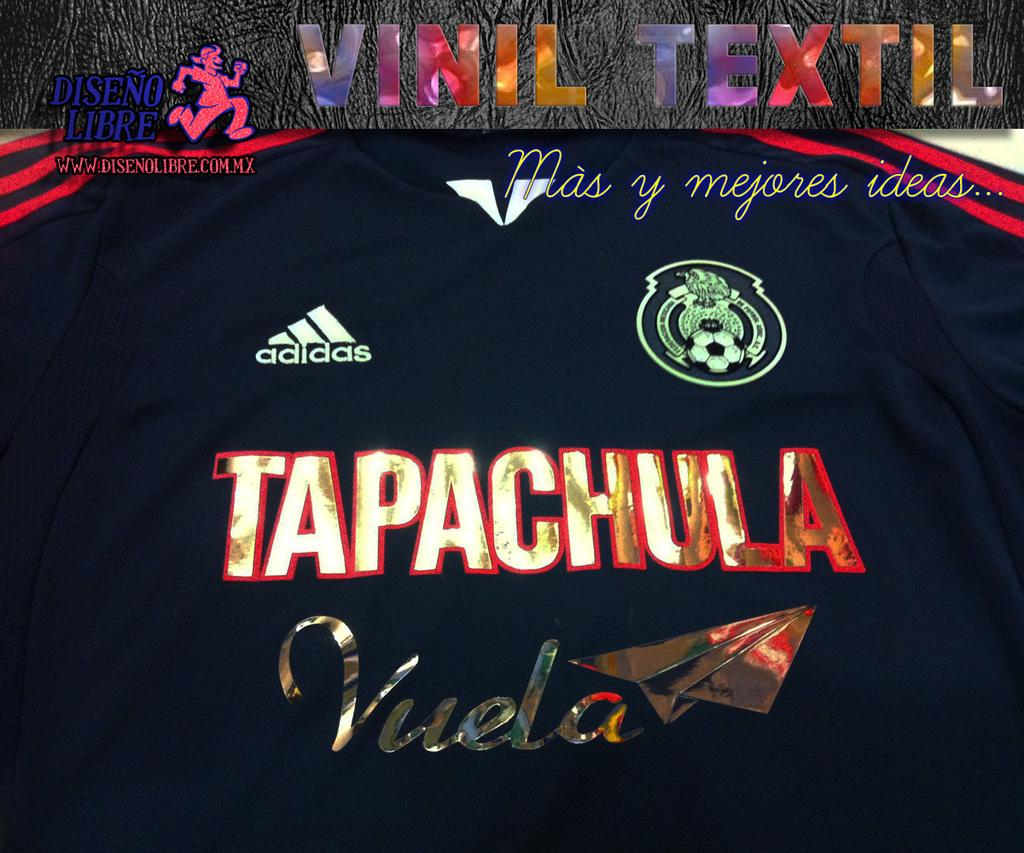<image>
Write a terse but informative summary of the picture. a sign that has the word Tapachula on it 